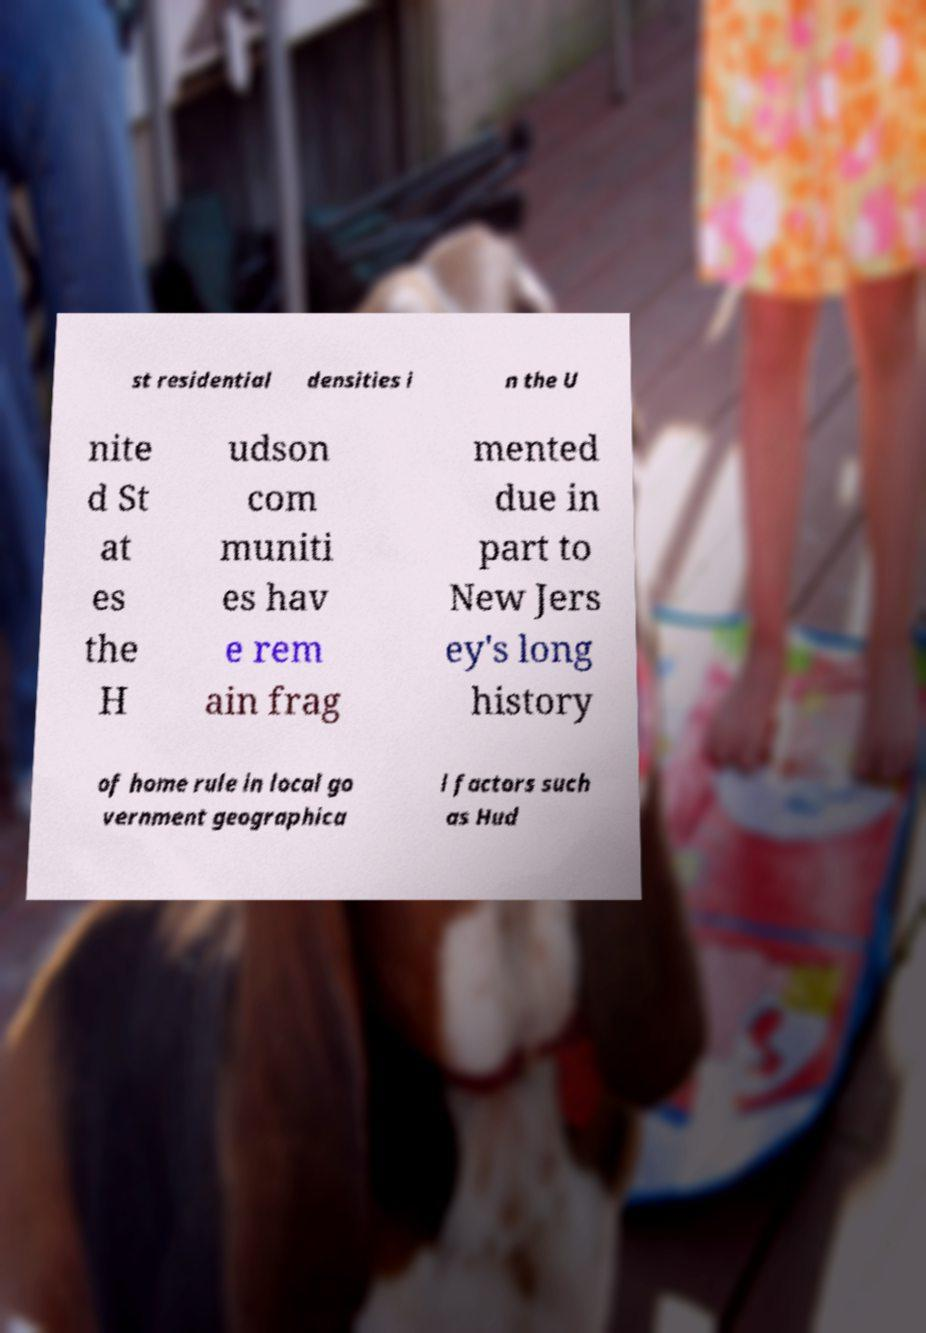Please read and relay the text visible in this image. What does it say? st residential densities i n the U nite d St at es the H udson com muniti es hav e rem ain frag mented due in part to New Jers ey's long history of home rule in local go vernment geographica l factors such as Hud 